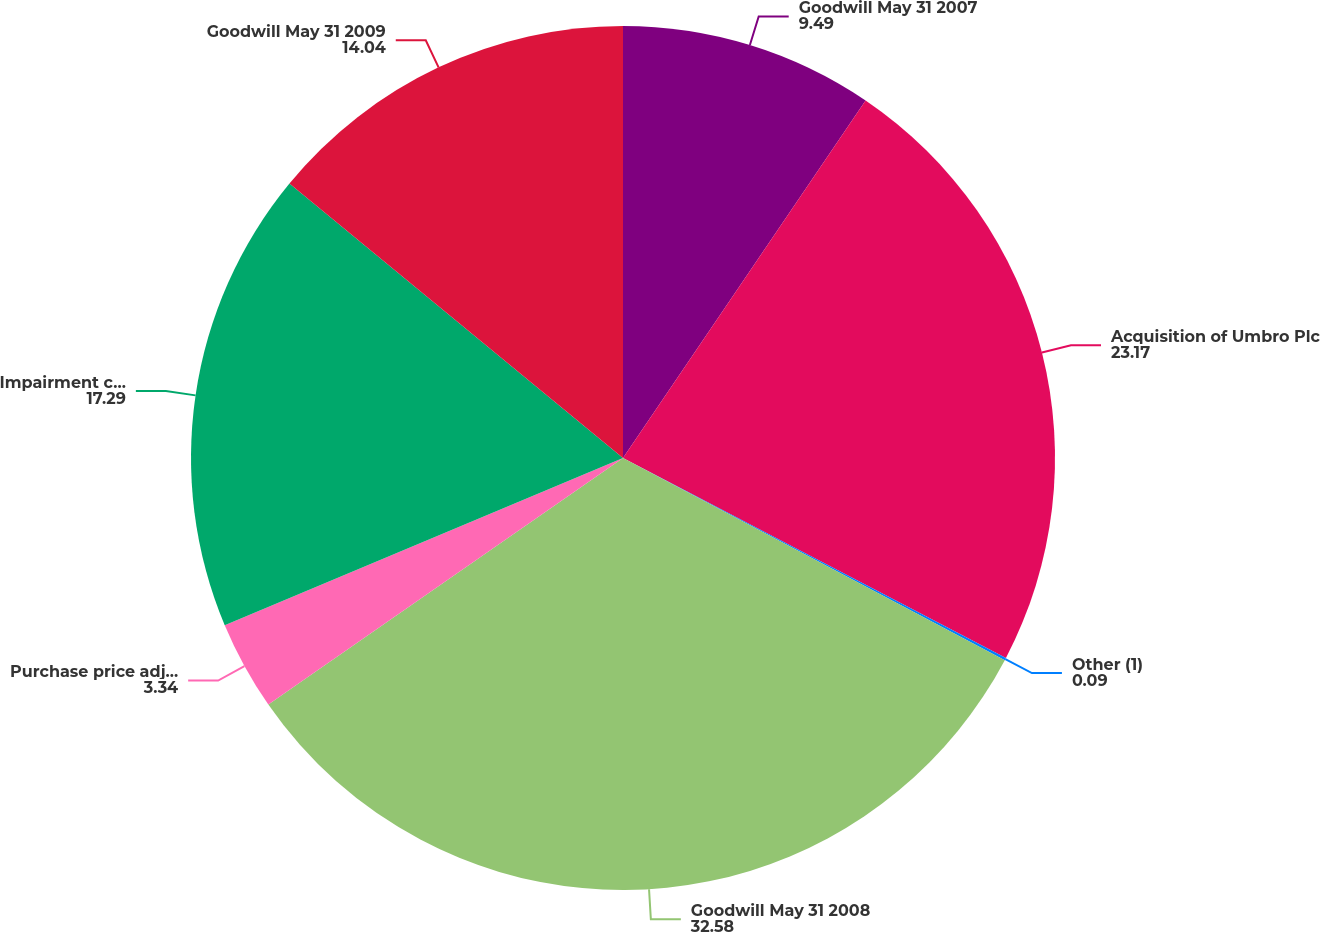Convert chart to OTSL. <chart><loc_0><loc_0><loc_500><loc_500><pie_chart><fcel>Goodwill May 31 2007<fcel>Acquisition of Umbro Plc<fcel>Other (1)<fcel>Goodwill May 31 2008<fcel>Purchase price adjustments<fcel>Impairment charge<fcel>Goodwill May 31 2009<nl><fcel>9.49%<fcel>23.17%<fcel>0.09%<fcel>32.58%<fcel>3.34%<fcel>17.29%<fcel>14.04%<nl></chart> 